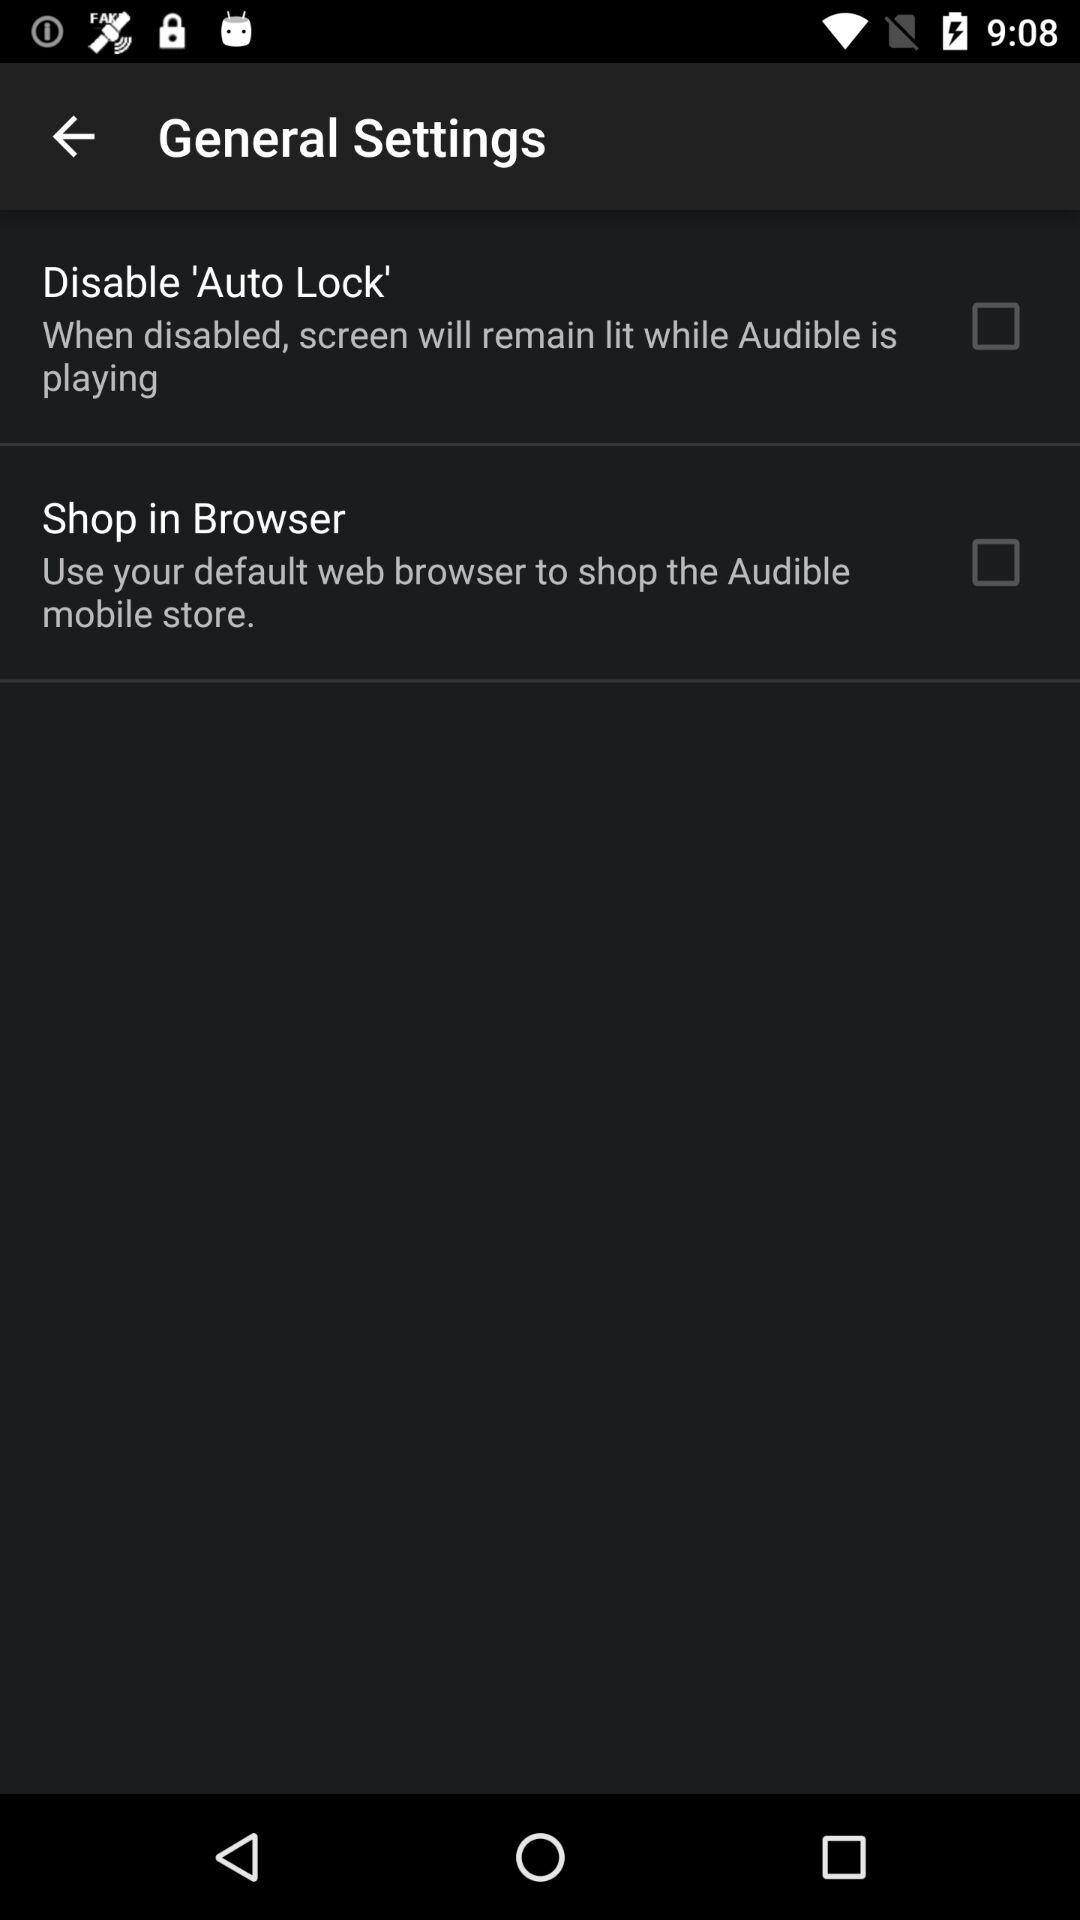What browser do we use to shop at the "Audible" mobile store? You can use the default web browser to shop at the "Audible" mobile store. 